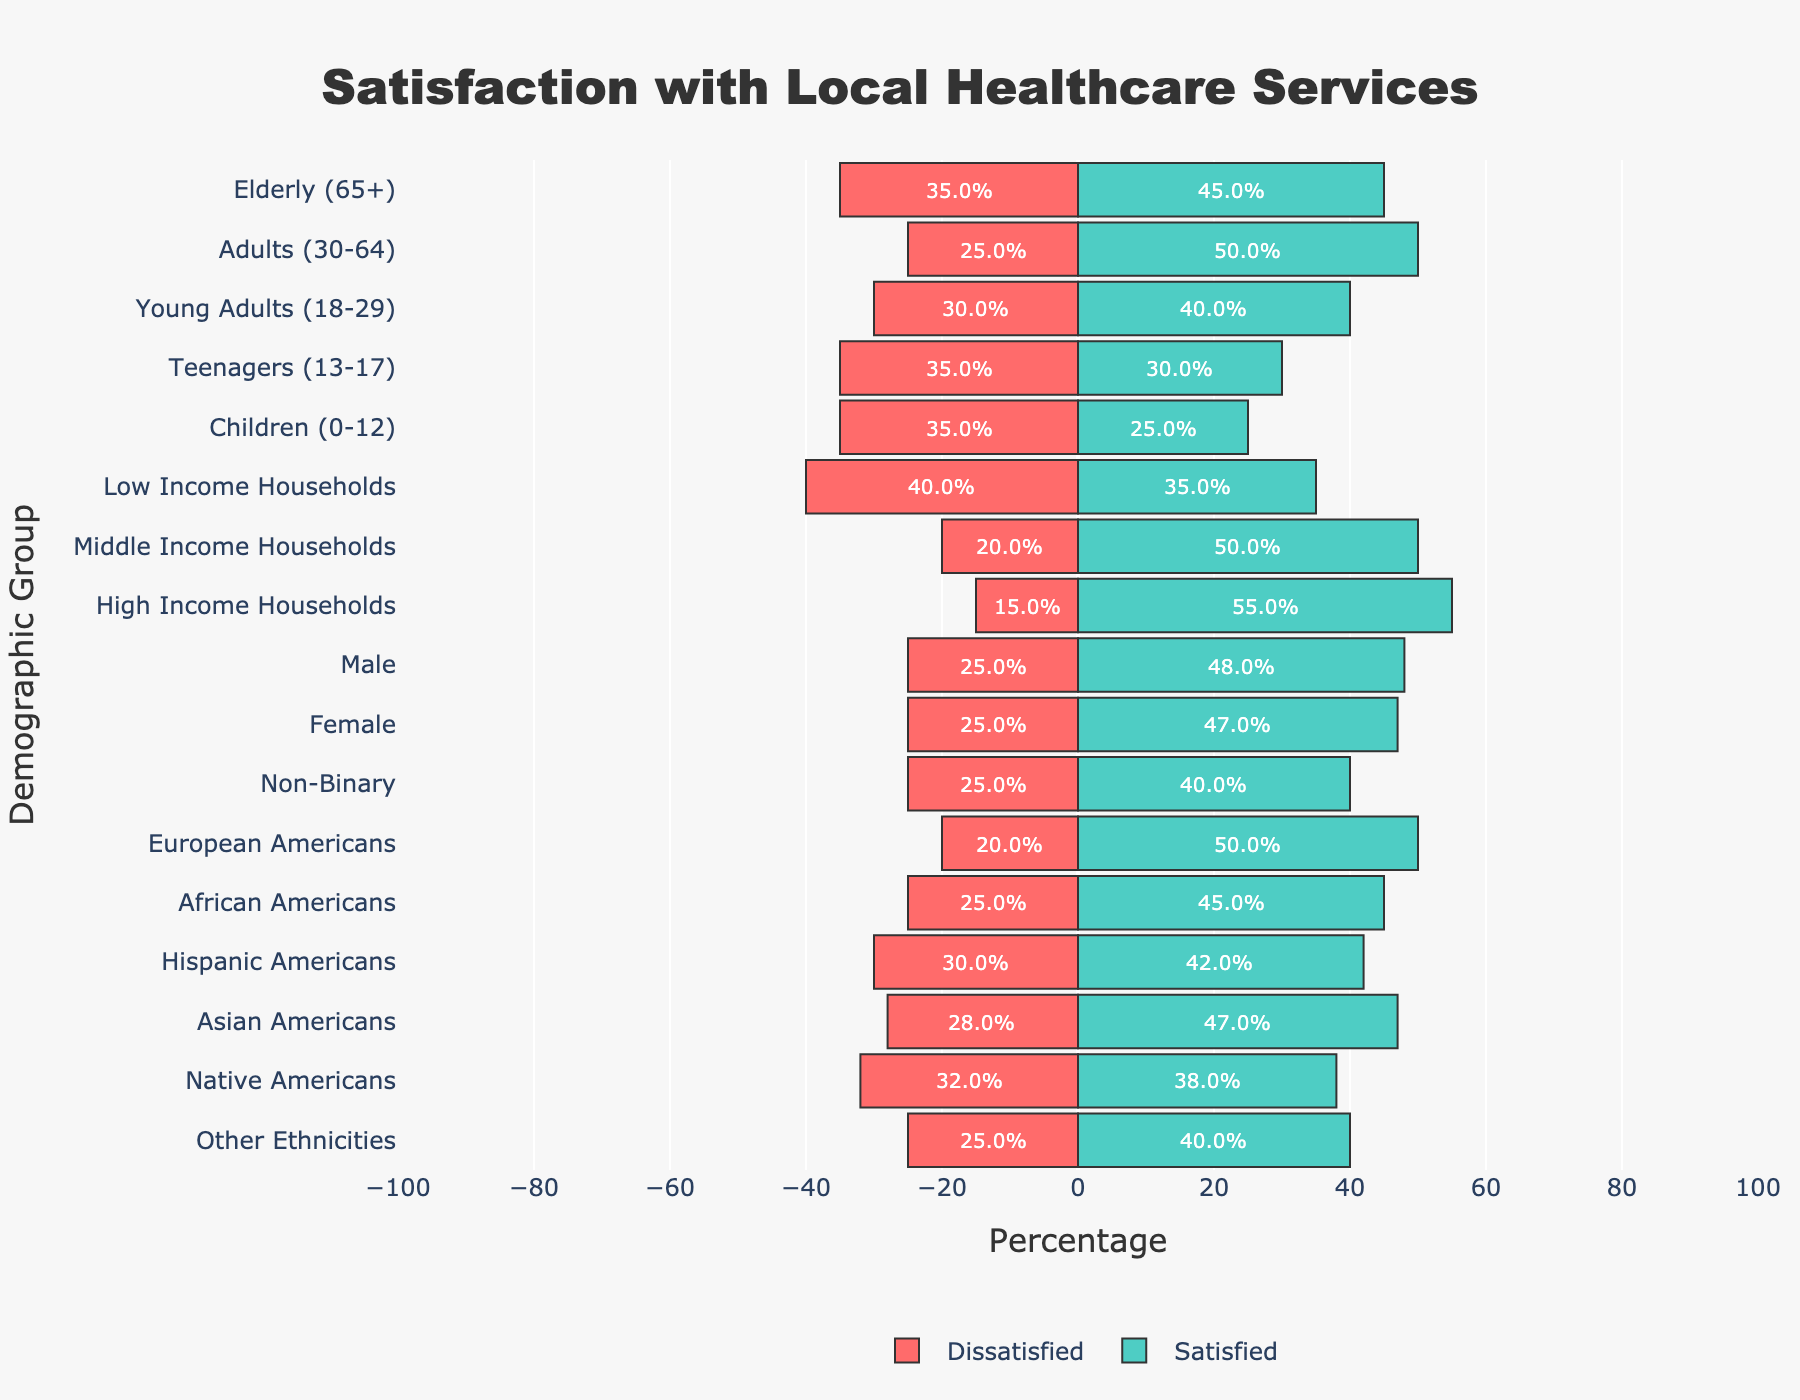What is the percentage of satisfied individuals among Young Adults and Teenagers? The percentage of satisfied individuals in Young Adults is 40%, and for Teenagers, it's 30%. To find the total percentage, add 40% + 30% = 70%. Divide by 2 to get the average: 70% / 2 = 35%.
Answer: 35% Which demographic group has the highest percentage of dissatisfied individuals? By comparing the dissatisfied percentages in the diverging bar chart, Low Income Households have the highest percentage of dissatisfied individuals at 40%.
Answer: Low Income Households Which group has a greater percentage of neutral individuals: Male or Non-Binary? From the diverging bar chart, Males have 27% neutral individuals, and Non-Binary has 35%. So, Non-Binary has a greater percentage of neutral individuals.
Answer: Non-Binary How does the percentage of satisfied individuals in High Income Households compare to African Americans? High Income Households have 55% satisfied individuals, while African Americans have 45%. High Income Households have a higher percentage of satisfied individuals.
Answer: High Income Households What is the difference in the percentage of dissatisfied individuals between Children and Elderly (65+)? Children have 35% dissatisfied individuals, and the Elderly (65+) also have 35% dissatisfied individuals. So, the difference is 35% - 35% = 0%.
Answer: 0% Among the listed ethnic groups, which has the lowest percentage of satisfied individuals? By referring to the satisfied percentages, Native Americans have the lowest percentage of satisfied individuals at 38%.
Answer: Native Americans Which has more dissatisfied individuals, Middle Income Households or Hispanic Americans? Middle Income Households have 20% dissatisfied individuals, and Hispanic Americans have 30%. Hispanic Americans have more dissatisfied individuals.
Answer: Hispanic Americans What is the combined percentage of neutral and dissatisfied individuals among Teenagers? Teenagers have 35% neutral and 35% dissatisfied individuals: 35% + 35% = 70%.
Answer: 70% Between Adults (30-64) and Young Adults (18-29), which group has a higher total percentage of neutral and satisfied individuals? Adults (30-64) have 50% satisfied and 25% neutral, totaling 75%. Young Adults (18-29) have 40% satisfied and 30% neutral, totaling 70%. Adults (30-64) have a higher total percentage.
Answer: Adults (30-64) 